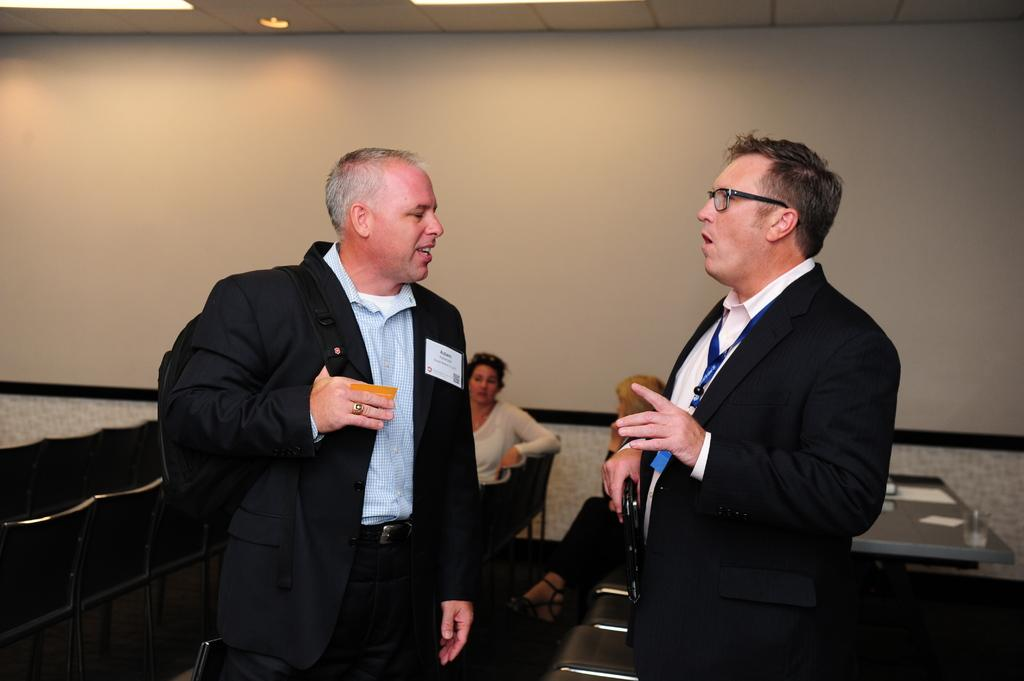Who or what is present in the image? There are people in the image. What is on the table in the image? There is a table with objects on it in the image. What furniture is visible in the image? There are chairs in the image. What architectural elements can be seen in the image? There is a wall and a roof visible in the image. What is on the roof in the image? There is a light on the roof in the image. What type of flowers are growing on the wall in the image? There are no flowers visible on the wall in the image. 